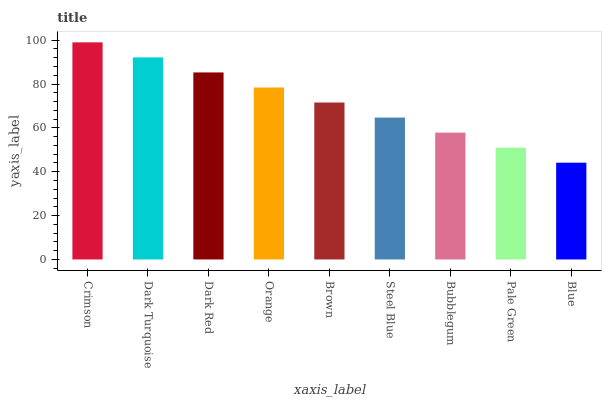Is Blue the minimum?
Answer yes or no. Yes. Is Crimson the maximum?
Answer yes or no. Yes. Is Dark Turquoise the minimum?
Answer yes or no. No. Is Dark Turquoise the maximum?
Answer yes or no. No. Is Crimson greater than Dark Turquoise?
Answer yes or no. Yes. Is Dark Turquoise less than Crimson?
Answer yes or no. Yes. Is Dark Turquoise greater than Crimson?
Answer yes or no. No. Is Crimson less than Dark Turquoise?
Answer yes or no. No. Is Brown the high median?
Answer yes or no. Yes. Is Brown the low median?
Answer yes or no. Yes. Is Orange the high median?
Answer yes or no. No. Is Orange the low median?
Answer yes or no. No. 